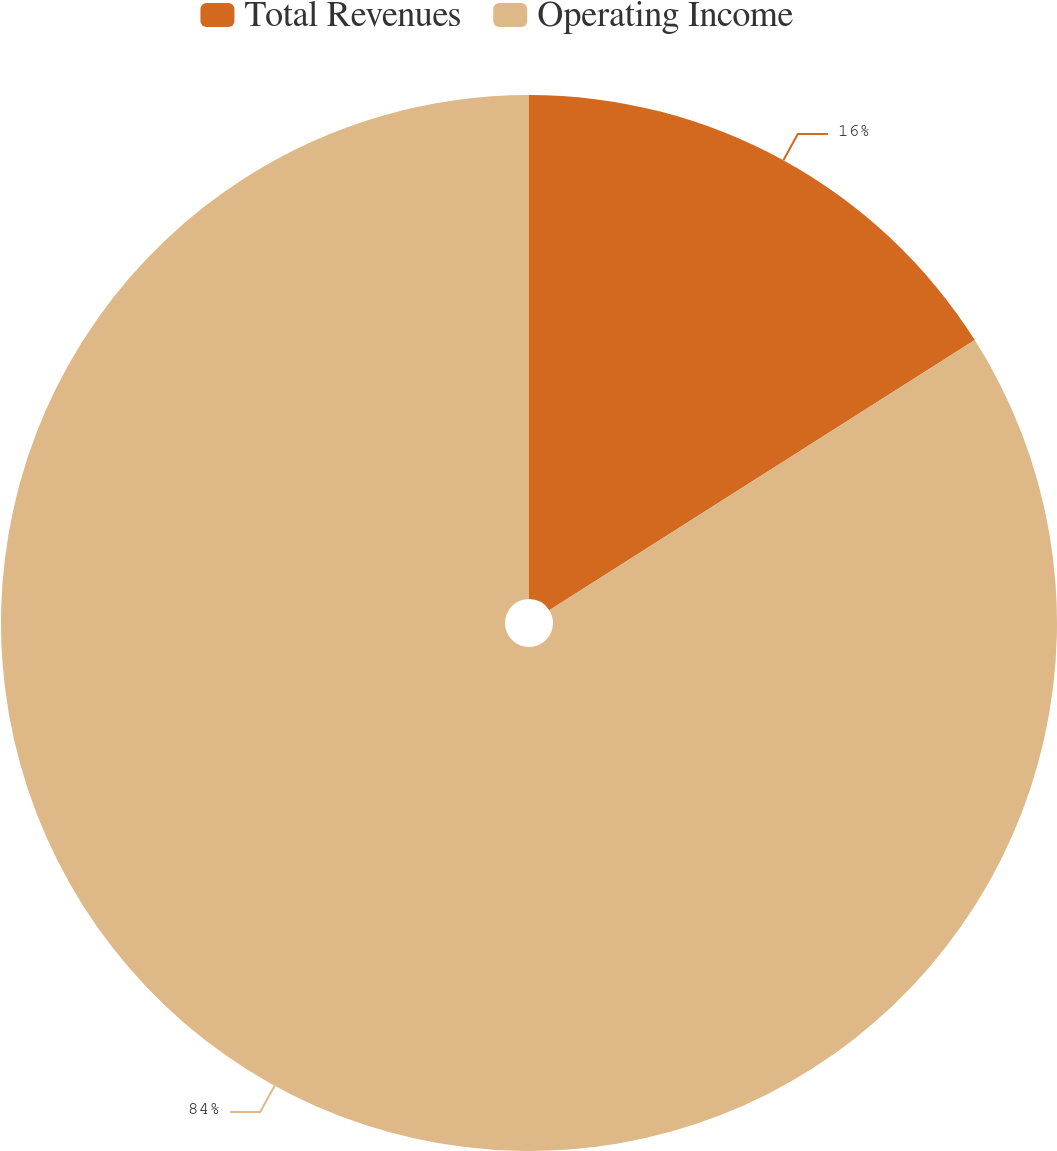Convert chart to OTSL. <chart><loc_0><loc_0><loc_500><loc_500><pie_chart><fcel>Total Revenues<fcel>Operating Income<nl><fcel>16.0%<fcel>84.0%<nl></chart> 